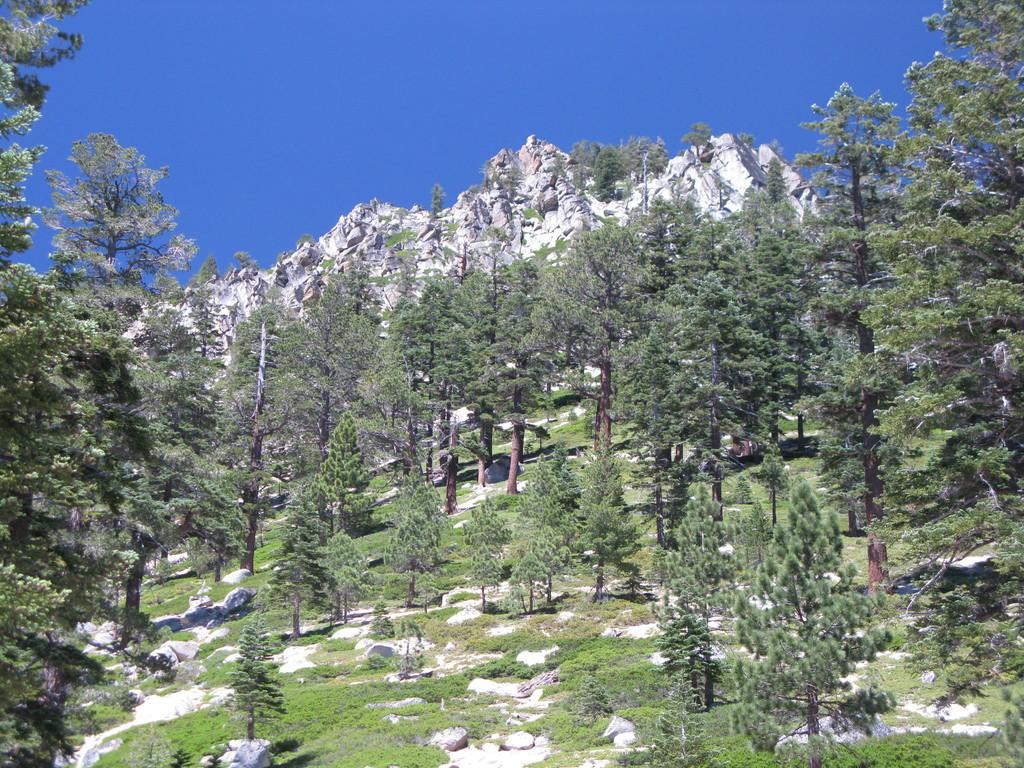What type of vegetation can be seen in the image? There are trees in the image. What is covering the ground in the image? There is grass on the ground in the image. What other natural elements are visible in the image? There are rocks visible in the image. What can be seen in the background of the image? The sky is clear and visible in the background of the image. What type of song can be heard playing in the background of the image? There is no sound or music present in the image, so it is not possible to determine what song might be playing. 